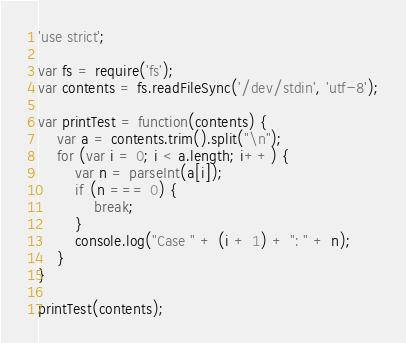<code> <loc_0><loc_0><loc_500><loc_500><_JavaScript_>'use strict';

var fs = require('fs');
var contents = fs.readFileSync('/dev/stdin', 'utf-8');

var printTest = function(contents) {
    var a = contents.trim().split("\n");
    for (var i = 0; i < a.length; i++) {
        var n = parseInt(a[i]);
        if (n === 0) {
            break;
        }
        console.log("Case " + (i + 1) + ": " + n);
    }
}

printTest(contents);</code> 